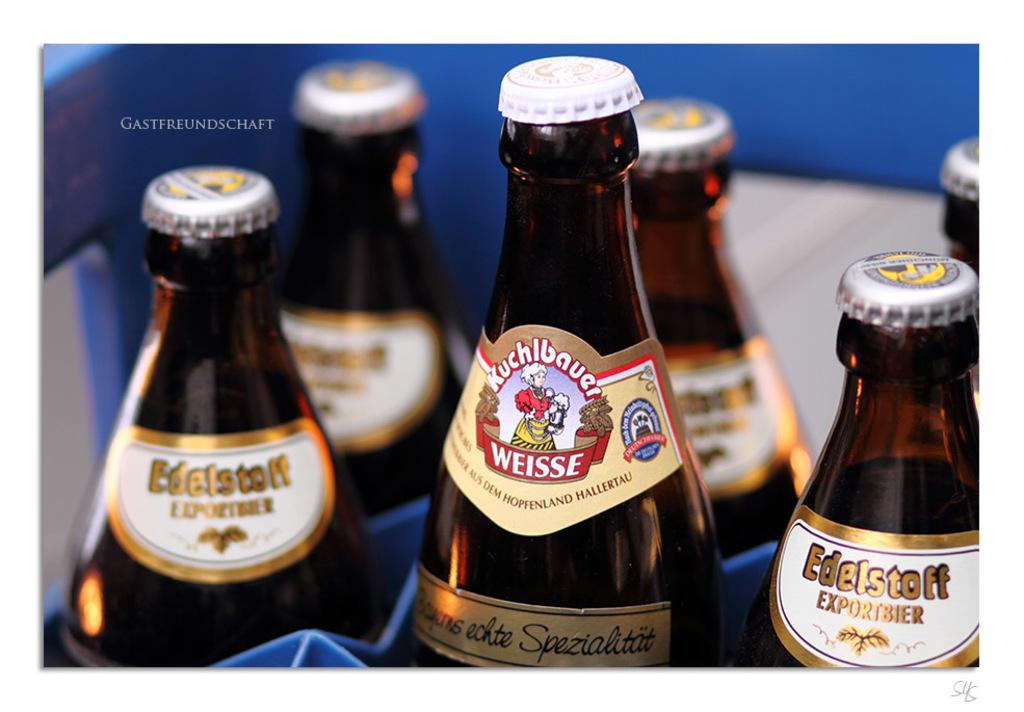<image>
Write a terse but informative summary of the picture. Edelstoff and other beer bottles are shown together. 